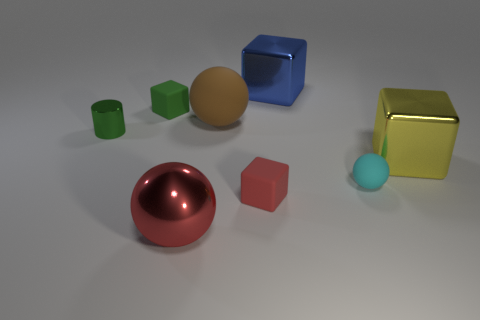Add 2 green cylinders. How many objects exist? 10 Subtract all spheres. How many objects are left? 5 Add 3 blue cubes. How many blue cubes exist? 4 Subtract 0 blue cylinders. How many objects are left? 8 Subtract all tiny yellow rubber cylinders. Subtract all blue metallic things. How many objects are left? 7 Add 6 spheres. How many spheres are left? 9 